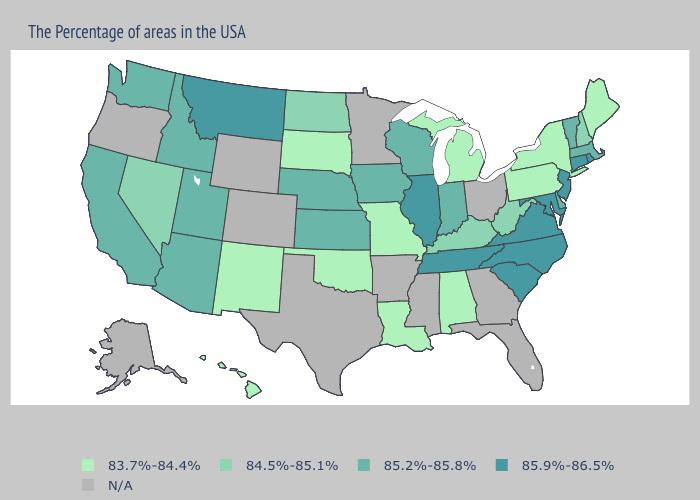What is the value of Virginia?
Keep it brief. 85.9%-86.5%. Name the states that have a value in the range N/A?
Be succinct. Ohio, Florida, Georgia, Mississippi, Arkansas, Minnesota, Texas, Wyoming, Colorado, Oregon, Alaska. How many symbols are there in the legend?
Quick response, please. 5. Among the states that border Washington , which have the lowest value?
Answer briefly. Idaho. Which states hav the highest value in the West?
Short answer required. Montana. Which states have the lowest value in the USA?
Write a very short answer. Maine, New York, Pennsylvania, Michigan, Alabama, Louisiana, Missouri, Oklahoma, South Dakota, New Mexico, Hawaii. What is the value of Alaska?
Quick response, please. N/A. What is the lowest value in the USA?
Concise answer only. 83.7%-84.4%. Among the states that border Illinois , which have the highest value?
Write a very short answer. Indiana, Wisconsin, Iowa. What is the value of Montana?
Be succinct. 85.9%-86.5%. Among the states that border Vermont , which have the highest value?
Write a very short answer. Massachusetts. Among the states that border Texas , which have the lowest value?
Short answer required. Louisiana, Oklahoma, New Mexico. What is the highest value in the MidWest ?
Write a very short answer. 85.9%-86.5%. 